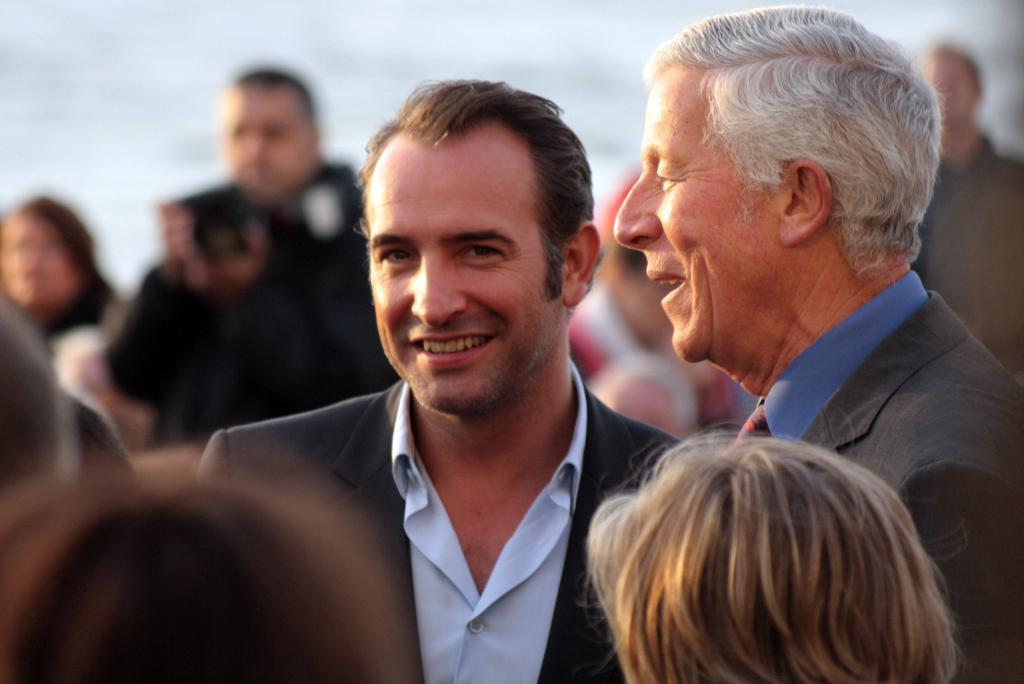What are the people in the image doing? There are people standing in the image. Can you describe the expressions of the people in the image? Two people are smiling in the image. What type of clothing are the people wearing? The people are wearing blazers and shirts. What can be seen in the background of the image? There is a man holding a camera in the background of the image. What is the average income of the people in the image? There is no information about the income of the people in the image, so it cannot be determined. 